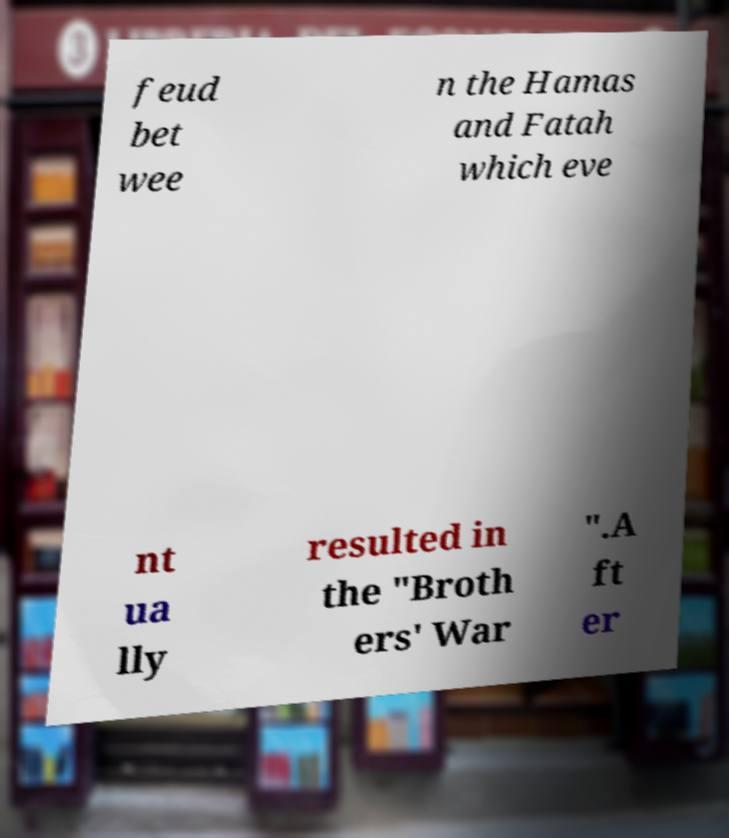I need the written content from this picture converted into text. Can you do that? feud bet wee n the Hamas and Fatah which eve nt ua lly resulted in the "Broth ers' War ".A ft er 